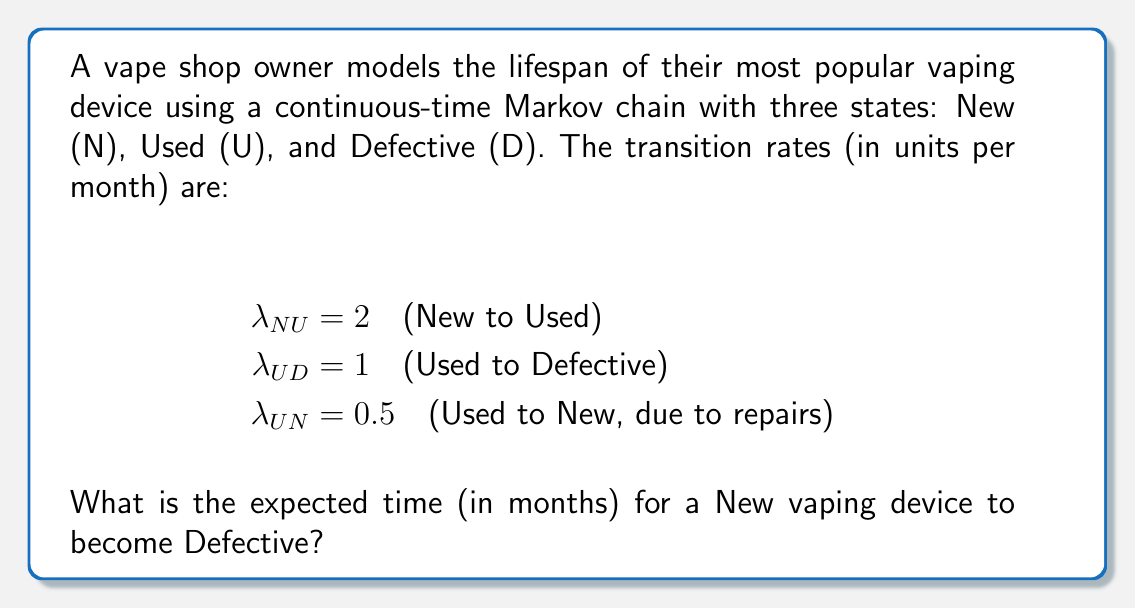Can you answer this question? To solve this problem, we'll use the concept of mean first passage time in continuous-time Markov chains.

Step 1: Define the states and transition rates matrix Q.
$$Q = \begin{bmatrix}
-2 & 2 & 0 \\
0.5 & -1.5 & 1 \\
0 & 0 & 0
\end{bmatrix}$$

Step 2: Remove the absorbing state (D) and create the fundamental matrix N.
$$N = -Q_{T}^{-1}$$
Where $Q_{T}$ is the transient states submatrix:
$$Q_{T} = \begin{bmatrix}
-2 & 2 \\
0.5 & -1.5
\end{bmatrix}$$

Step 3: Calculate $N = -Q_{T}^{-1}$
$$N = -\begin{bmatrix}
-2 & 2 \\
0.5 & -1.5
\end{bmatrix}^{-1} = \begin{bmatrix}
0.75 & 1 \\
0.25 & 1
\end{bmatrix}$$

Step 4: The expected time to absorption (Defective state) from the New state is the sum of the first row of N.

Expected time = $0.75 + 1 = 1.75$ months
Answer: 1.75 months 